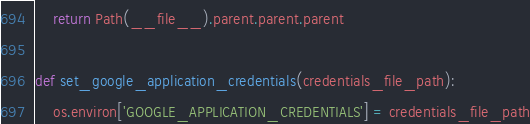Convert code to text. <code><loc_0><loc_0><loc_500><loc_500><_Python_>    return Path(__file__).parent.parent.parent

def set_google_application_credentials(credentials_file_path):
    os.environ['GOOGLE_APPLICATION_CREDENTIALS'] = credentials_file_path
</code> 